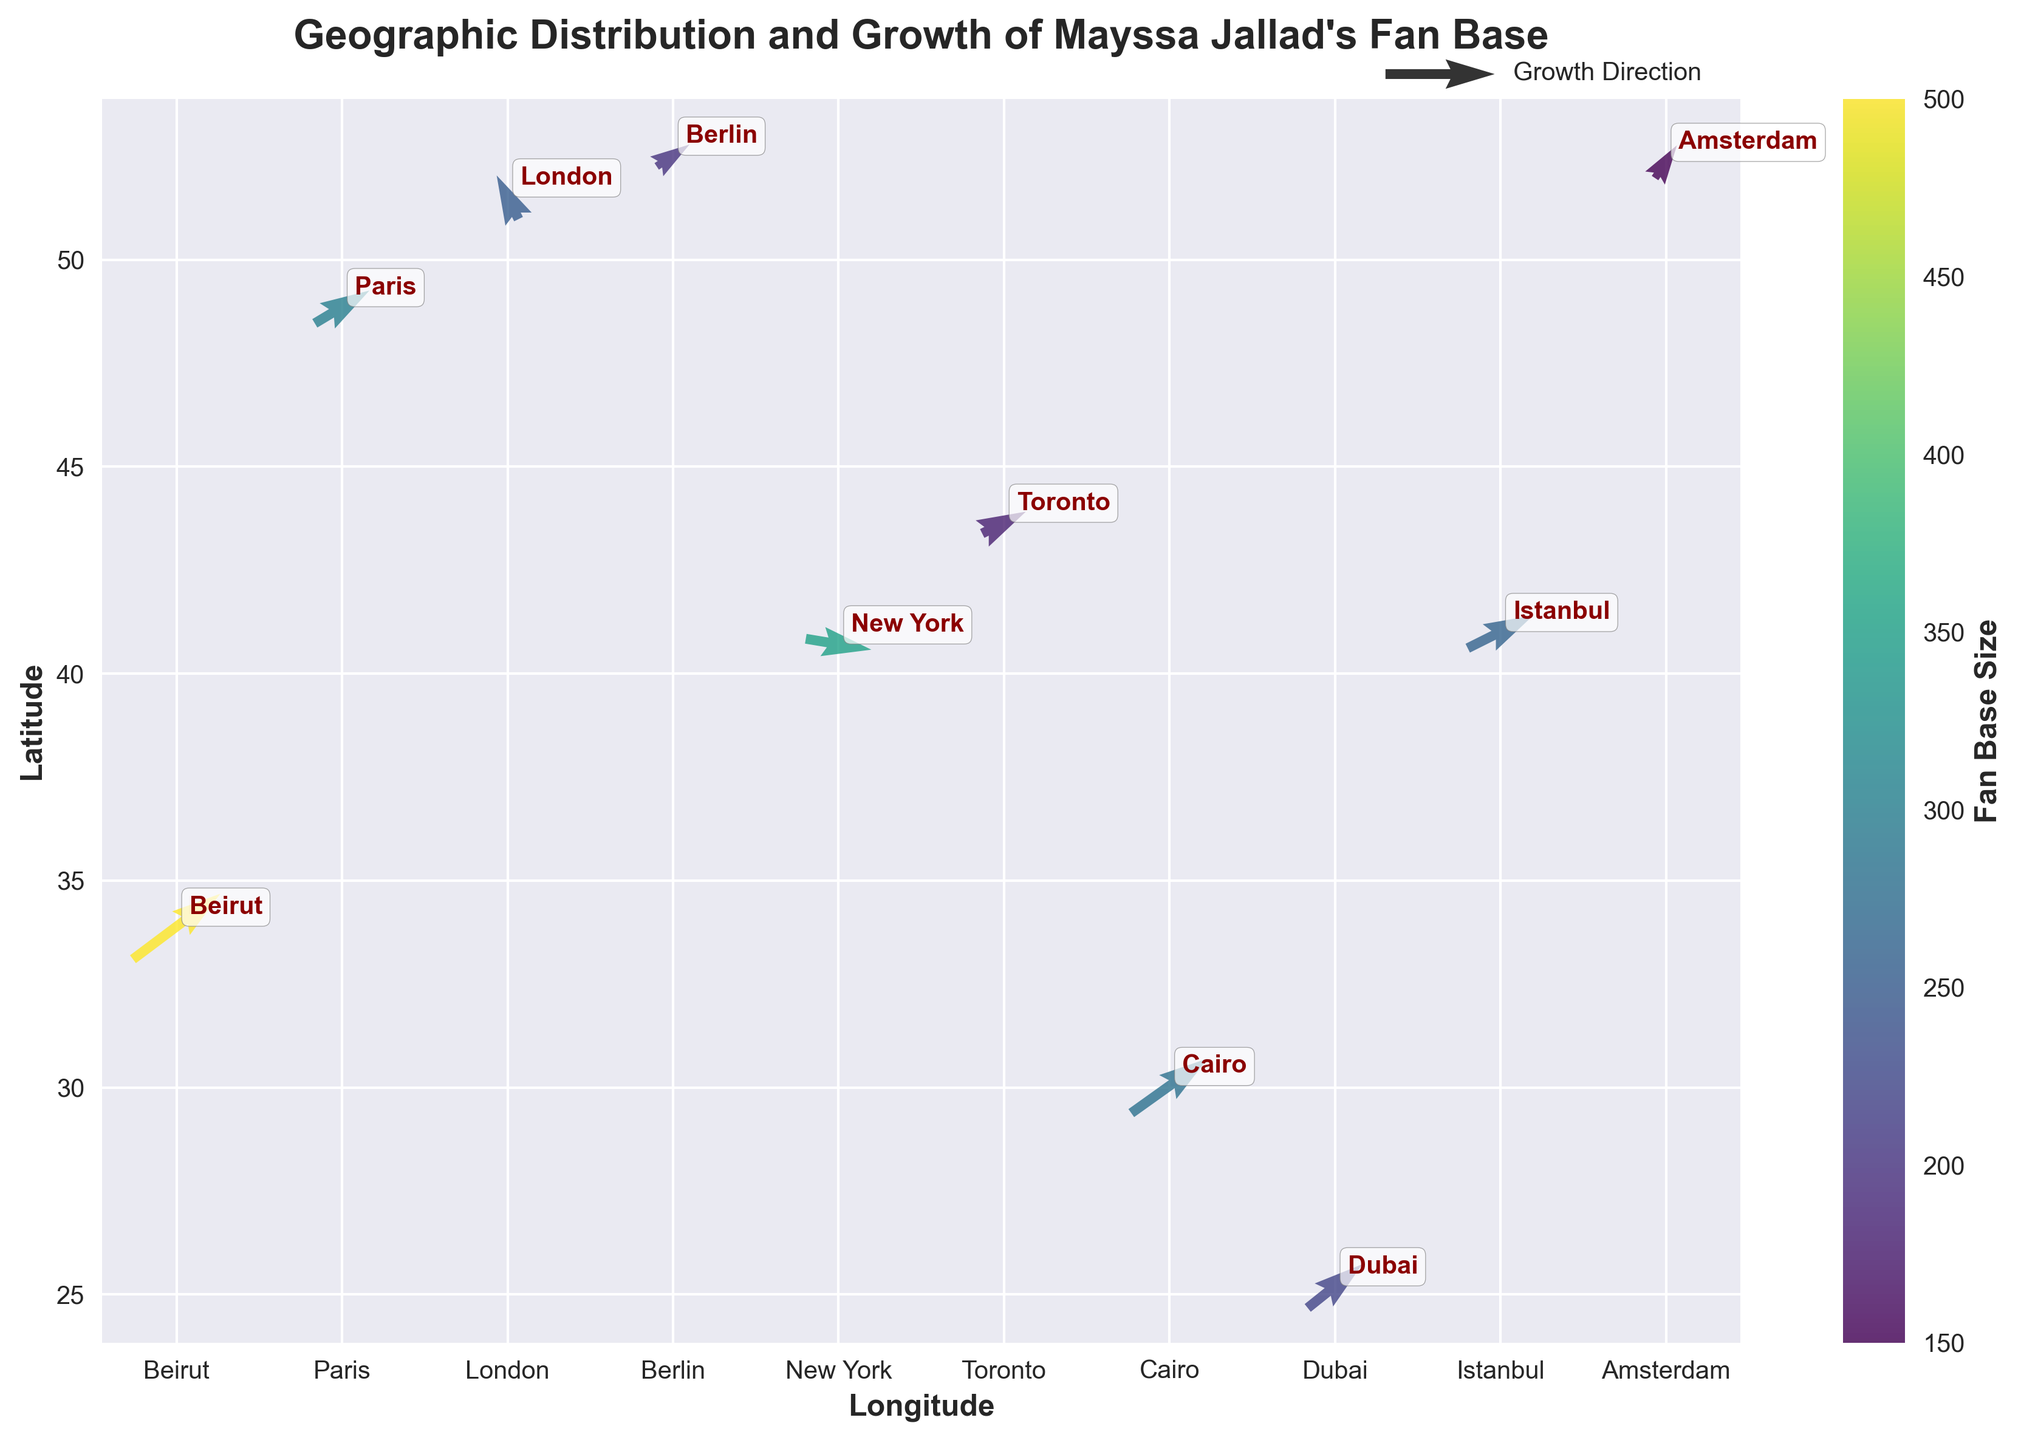What is the title of the figure? The title is located at the top of the figure, describing the content of the plot, which helps to understand the context.
Answer: Geographic Distribution and Growth of Mayssa Jallad's Fan Base How many cities are shown in the plot? Count the number of city labels annotated on the figure.
Answer: 10 Which city has the largest fan base size? Look for the arrow with the highest magnitude and its corresponding city label. The color intensity of the arrow can also help, as more intense colors correspond to larger magnitudes.
Answer: Beirut Which direction is the fan base growing in Berlin? Observe the direction of the arrow originating from Berlin. The direction indicates the trend of growth.
Answer: East-Northeast Compare the growth trends of New York and Beirut. Which city shows outward growth from the center? Check the directions of the arrows starting from New York and Beirut. Outward growth from the center means moving away from the origin point of the arrow.
Answer: New York Which city shows a decrease or negative trend in growth in the y-direction? Negative growth in the y-direction means the arrow points downward. Check each city's arrow direction along the y-axis.
Answer: New York Is the fan base growth in London more horizontal or vertical? Analyze the u (horizontal) and v (vertical) components of the arrow originating from London; the higher value will dictate the dominant direction.
Answer: Vertical Calculate the average magnitude of the fan base sizes across all cities. Sum the magnitude values of all cities and divide by the total number of cities.
Answer: (500 + 300 + 250 + 200 + 350 + 180 + 280 + 220 + 260 + 150) / 10 = 269 What is the predominant color used in the arrows, and what does it signify? Observe the colors of the arrows and refer to the color bar that maps colors to fan base sizes.
Answer: Yellow-Green, signifying medium fan base size 